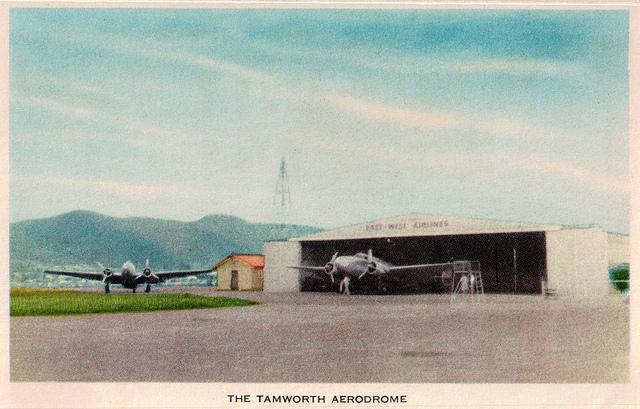Where is the silver plane on the right being stored? Please explain your reasoning. hanger. The other options don't work in this setting and an a is the standard option. 